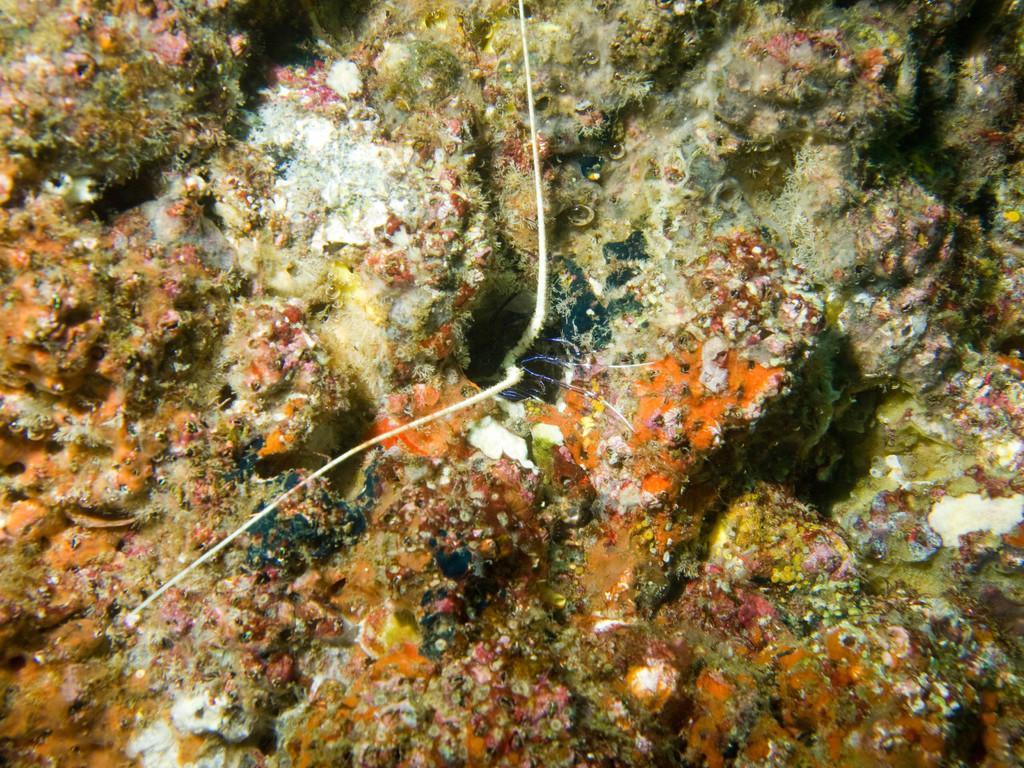Can you describe this image briefly? This image consists of submarine plants in the water. This image is taken may be in the ocean. 